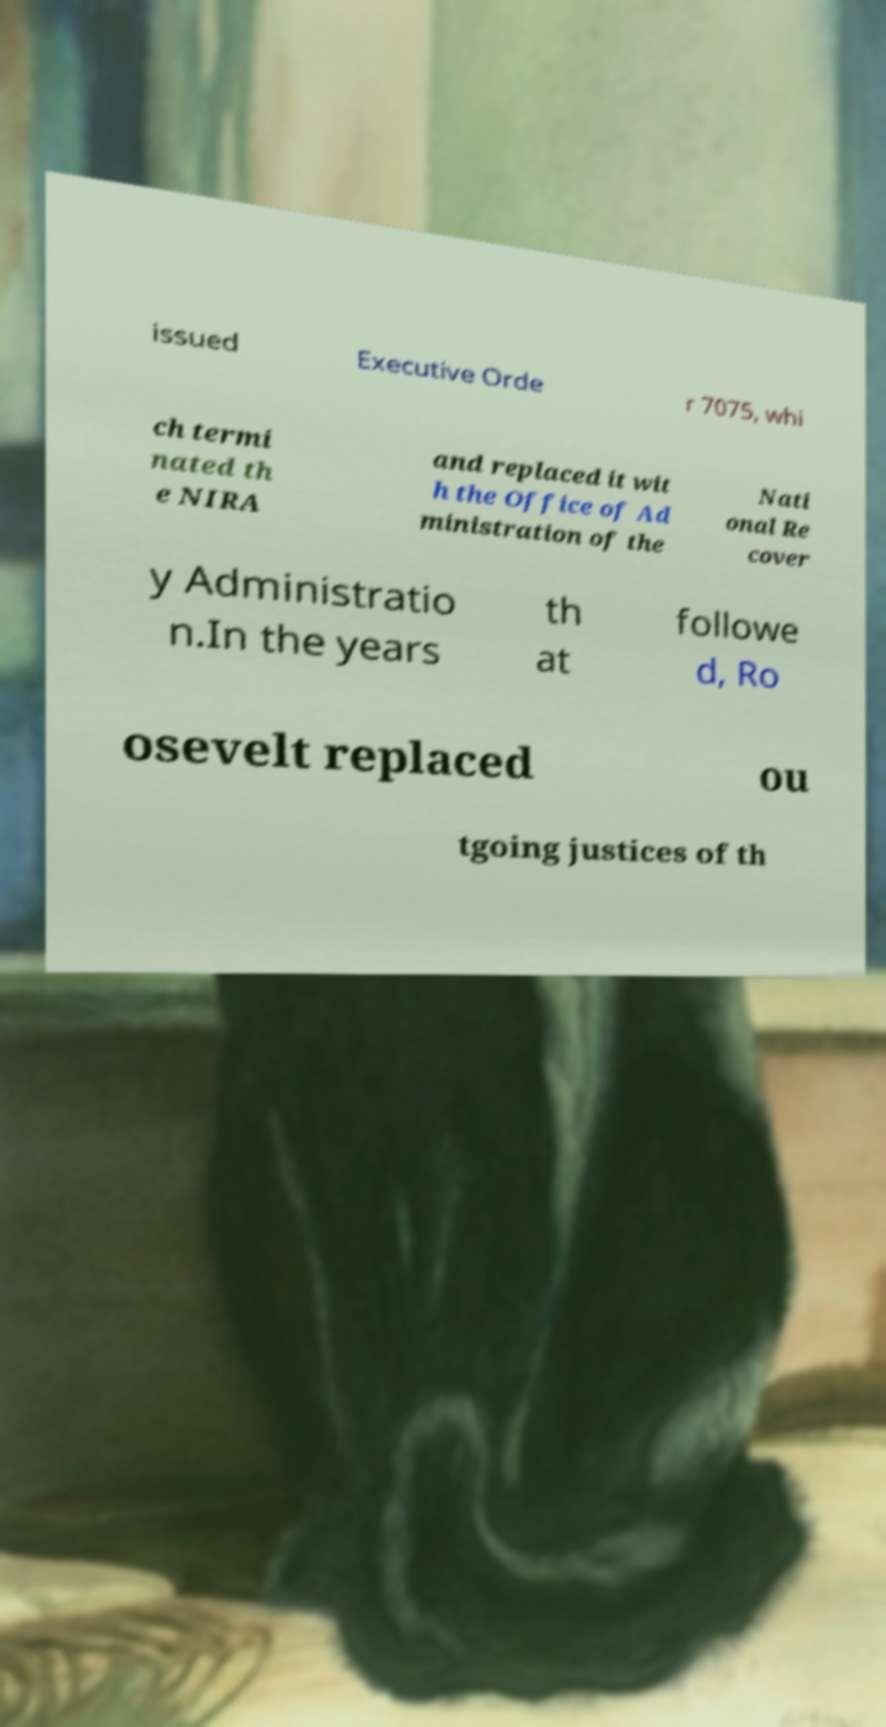What messages or text are displayed in this image? I need them in a readable, typed format. issued Executive Orde r 7075, whi ch termi nated th e NIRA and replaced it wit h the Office of Ad ministration of the Nati onal Re cover y Administratio n.In the years th at followe d, Ro osevelt replaced ou tgoing justices of th 